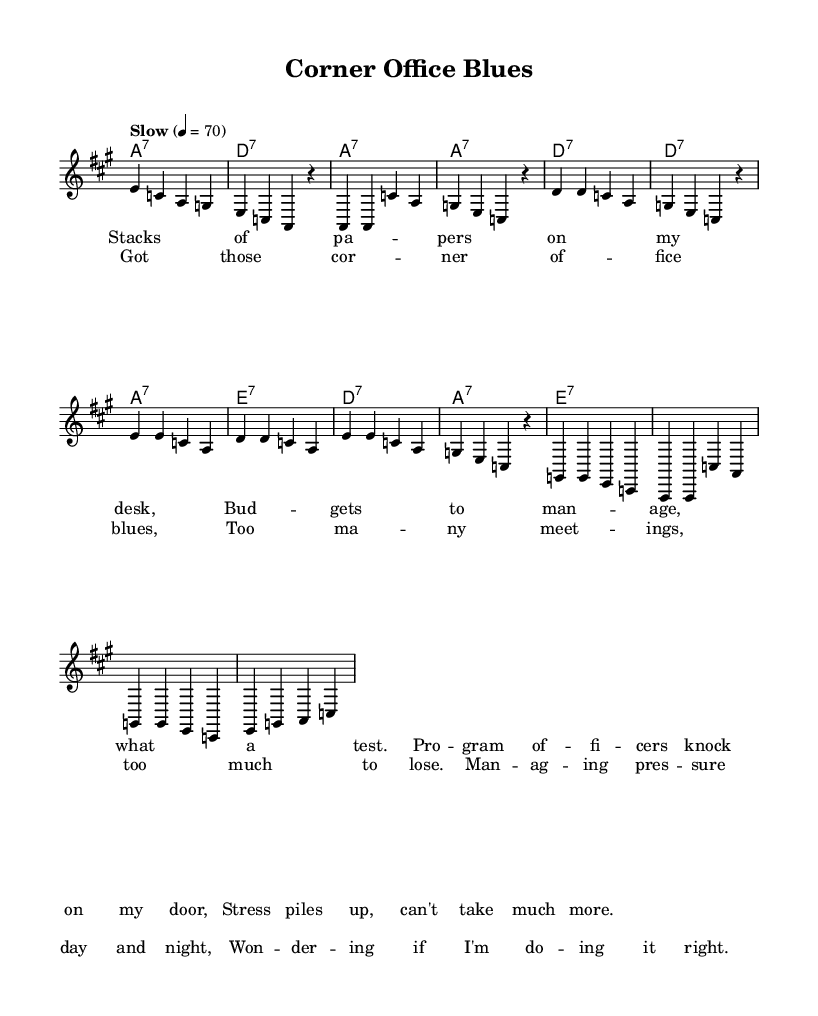What is the key signature of this music? The key signature is A major, indicated by three sharps in the beginning of the score.
Answer: A major What is the time signature of this music? The time signature is 4/4, which means there are four beats in each measure. This is visible at the beginning of the score next to the key signature.
Answer: 4/4 What is the tempo marking for this piece? The tempo marking is "Slow" with a metronome marking of quarter note = 70, indicating the speed at which the piece should be played.
Answer: Slow, 4 = 70 How many verses are in the song? The song contains two verses based on the arrangement and structure shown in the sheet music, along with the chorus.
Answer: Two In which section do we find the lyrics discussing workplace stress? The lyrics discussing workplace stress are found in the verse section, specifically in the first verse. The text addresses the challenges faced in managing stress at work.
Answer: Verse What musical form does this piece follow? The piece follows a common structure found in Blues music, typically consisting of verses followed by a chorus; in this case, it has one verse followed by the chorus.
Answer: Verse-Chorus What type of harmony is used in this piece? The harmony used in this piece is seventh chords, as indicated by the chord names which follow a pattern typical of the Blues genre, enhancing the harmonic texture.
Answer: Seventh chords 